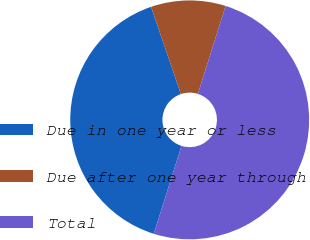<chart> <loc_0><loc_0><loc_500><loc_500><pie_chart><fcel>Due in one year or less<fcel>Due after one year through<fcel>Total<nl><fcel>39.9%<fcel>10.1%<fcel>50.0%<nl></chart> 